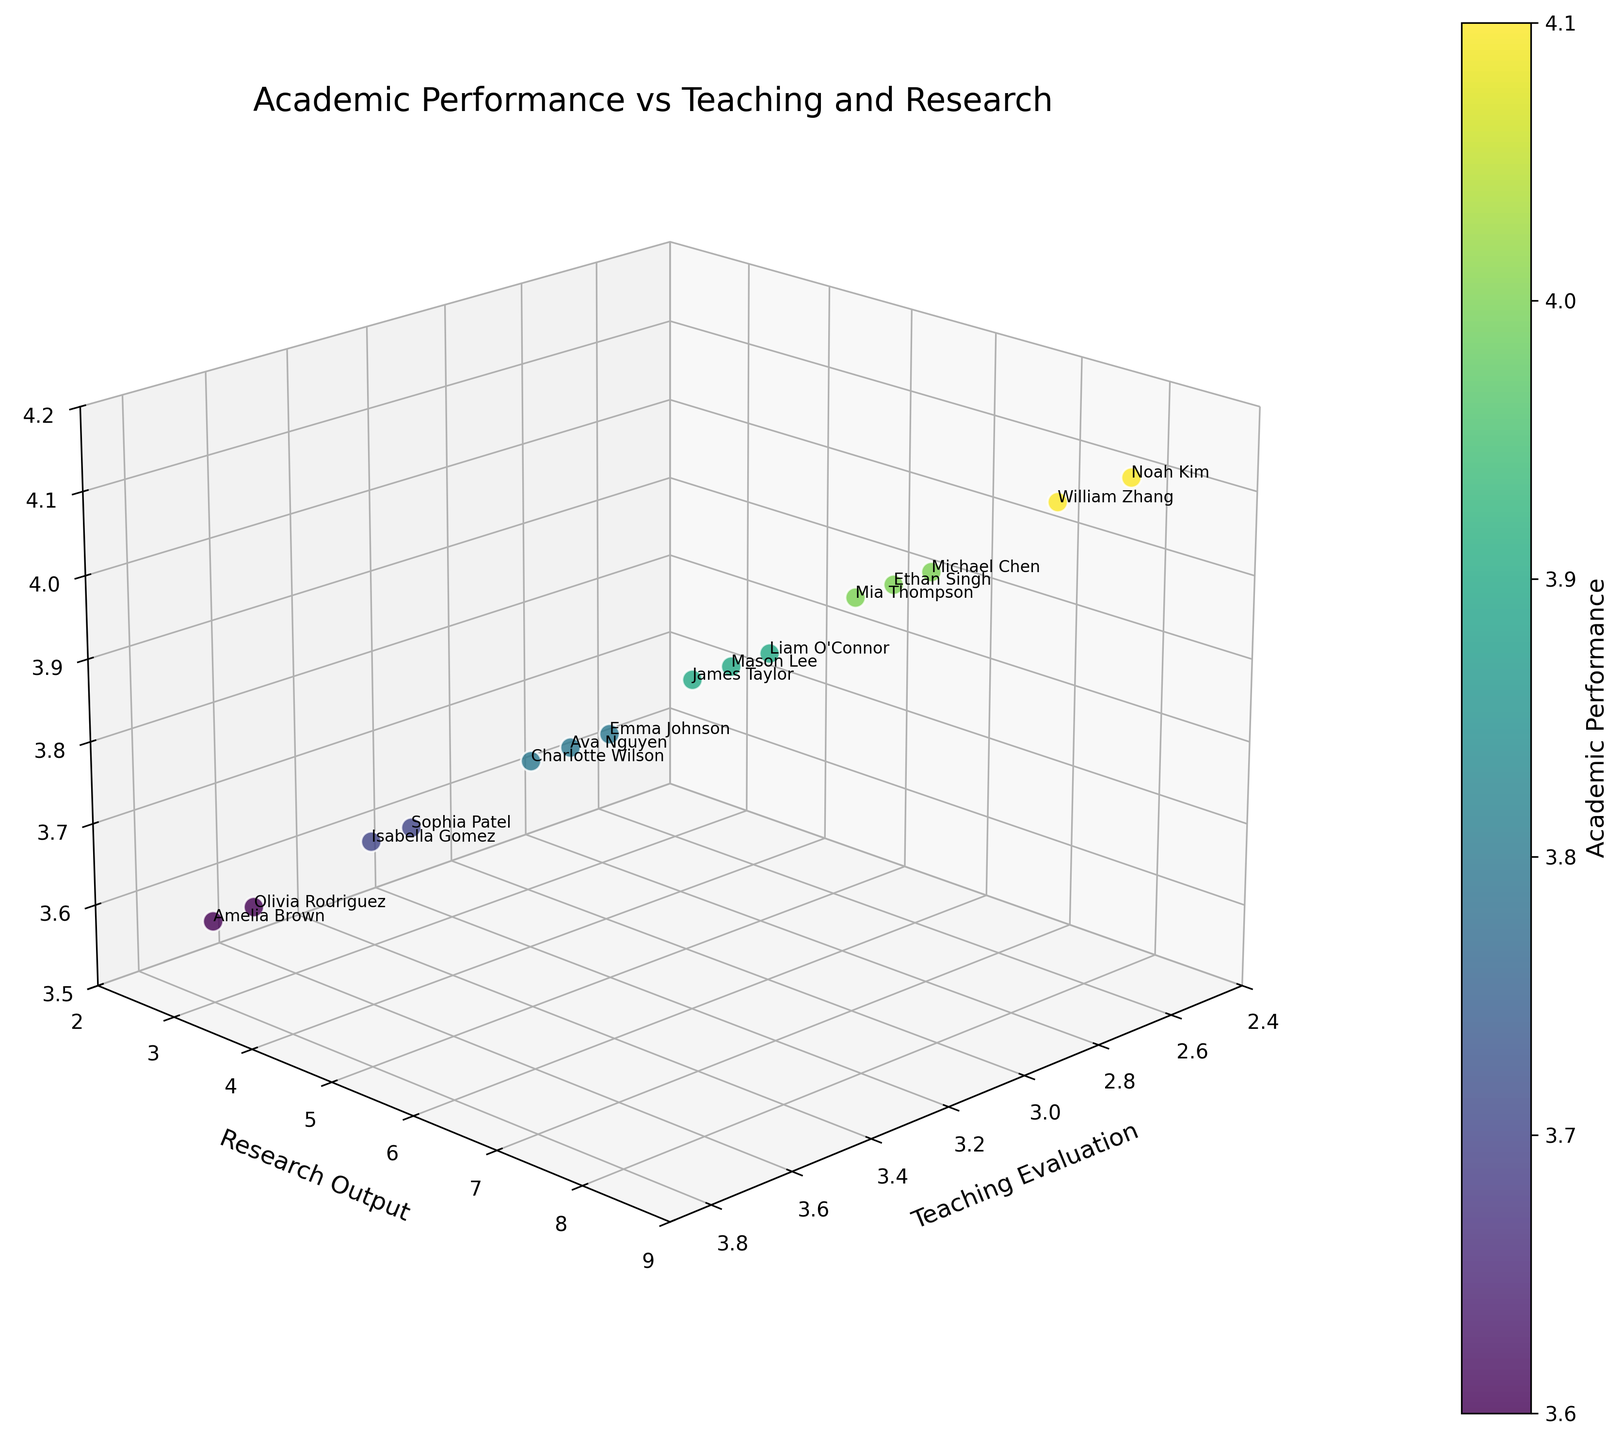How many students are represented in the plot? The x-axis, y-axis, and z-axis data points are each associated with a different student. Count the number of data points or look for labels associated with each point. There are a total of 15 labels corresponding to each student.
Answer: 15 Which student has the highest academic performance? The color intensity in the scatter plot indicates academic performance. Noah Kim and William Zhang are the data points with the highest values on the z-axis.
Answer: Noah Kim and William Zhang What is the relationship between teaching evaluation and academic performance for Emma Johnson? Locate the data point for Emma Johnson by using the labels. Emma Johnson has a teaching evaluation of 3.2 and an academic performance of 3.8. A moderate teaching evaluation corresponds to a good academic performance in her case, suggesting a potential positive relationship.
Answer: Positive relationship What is the range of research output among the students? Observe the y-axis (Research Output) of the scatter plot. The lowest value is 3 and the highest is 8, thus the range is 8 - 3 = 5.
Answer: 5 Which student has a higher teaching evaluation, Sophia Patel or Isabella Gomez? Find the corresponding data points for Sophia Patel and Isabella Gomez by identifying their labels. Sophia Patel has a teaching evaluation of 3.5, while Isabella Gomez has 3.6.
Answer: Isabella Gomez Which student has the lowest teaching evaluation but a high academic performance? Identify the data point with the lowest teaching evaluation visually by looking at the x-axis. Noah Kim has a teaching evaluation of 2.5 but still maintains an academic performance of 4.1.
Answer: Noah Kim What's the average academic performance for students with exactly 7 research output? Locate all data points with a y-axis value of 7. The students are Michael Chen, Ethan Singh, and Mia Thompson with academic performances of 4.0, 4.0, and 4.0 respectively. The average is (4.0 + 4.0 + 4.0) / 3 = 4.0.
Answer: 4.0 Does a higher research output always correspond to higher academic performance? Visually inspect the scatter plot for any trends. Though higher research output generally corresponds to higher academic performance, this is not strictly always the case; for instance, Olivia Rodriguez with a lower research output (3) has a moderate academic performance of 3.6.
Answer: No Which student has the closest values in all three dimensions (teaching evaluation, research output, and academic performance)? Look for data points clustered closely together or compare the coordinates of each point. Emma Johnson has values of 3.2 (teaching evaluation), 5 (research output), and 3.8 (academic performance), which are close to each other within their respective ranges.
Answer: Emma Johnson 